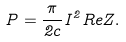Convert formula to latex. <formula><loc_0><loc_0><loc_500><loc_500>P = \frac { \pi } { 2 c } I ^ { 2 } R e Z .</formula> 